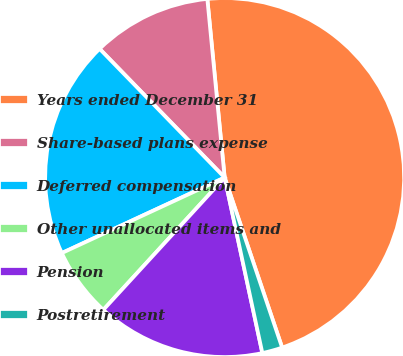Convert chart to OTSL. <chart><loc_0><loc_0><loc_500><loc_500><pie_chart><fcel>Years ended December 31<fcel>Share-based plans expense<fcel>Deferred compensation<fcel>Other unallocated items and<fcel>Pension<fcel>Postretirement<nl><fcel>46.35%<fcel>10.73%<fcel>19.64%<fcel>6.28%<fcel>15.18%<fcel>1.82%<nl></chart> 